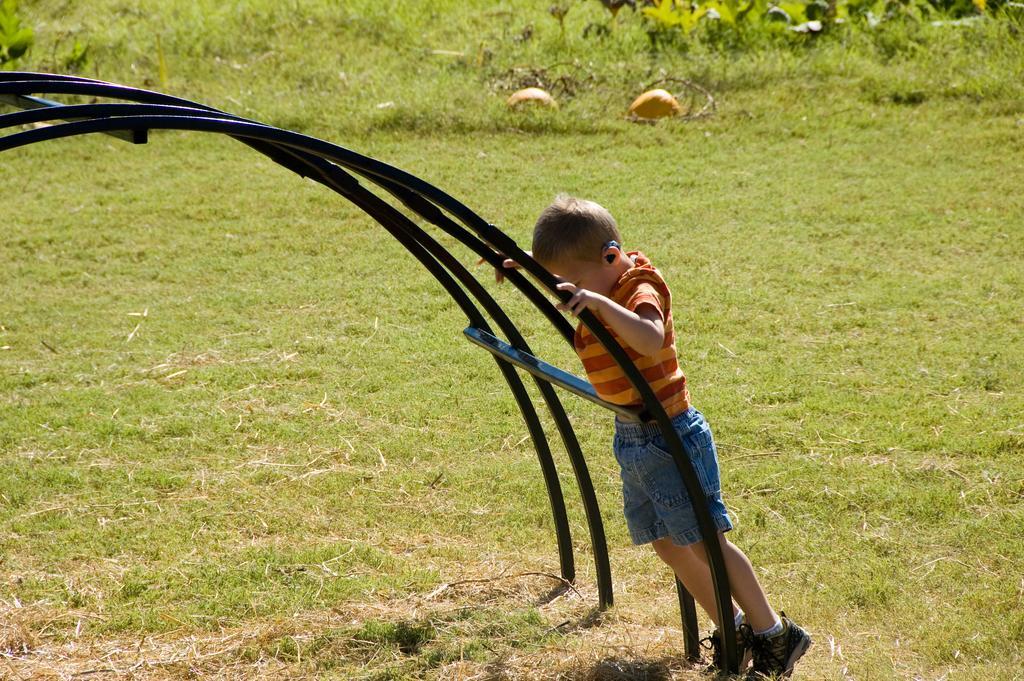Please provide a concise description of this image. In this picture we can see a boy is standing on the path and on the left side of the boy there are iron rods. Behind the boy there are plants and the grass. 